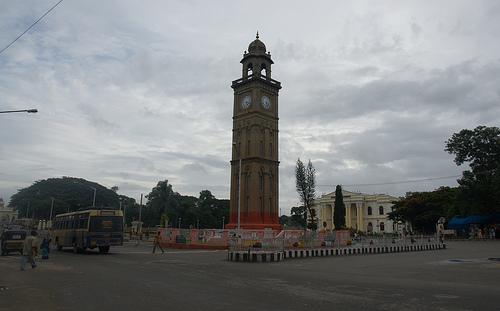Are the leaves changing color?
Give a very brief answer. No. Is this a construction site?
Keep it brief. Yes. How many palm trees are in the picture?
Be succinct. 0. Is one of the buildings a lot taller than the others?
Write a very short answer. Yes. Does the bell tower have a balcony?
Give a very brief answer. Yes. Are there mountains in the background?
Give a very brief answer. No. What is this structure?
Short answer required. Clock tower. What is the weather?
Short answer required. Cloudy. 